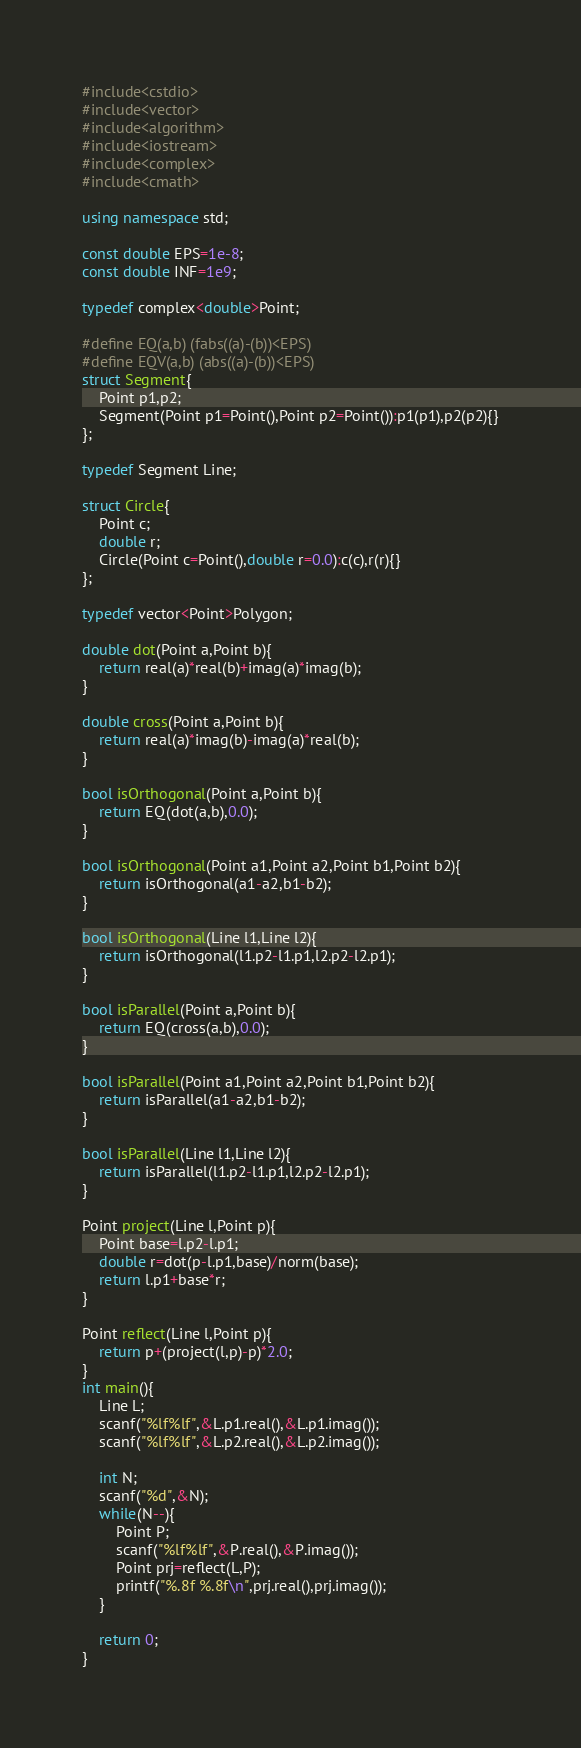<code> <loc_0><loc_0><loc_500><loc_500><_C++_>#include<cstdio>
#include<vector>
#include<algorithm>
#include<iostream>
#include<complex>
#include<cmath>

using namespace std;

const double EPS=1e-8;
const double INF=1e9;

typedef complex<double>Point;

#define EQ(a,b) (fabs((a)-(b))<EPS)
#define EQV(a,b) (abs((a)-(b))<EPS)
struct Segment{
    Point p1,p2;
    Segment(Point p1=Point(),Point p2=Point()):p1(p1),p2(p2){}
};

typedef Segment Line;

struct Circle{
    Point c;
    double r;
    Circle(Point c=Point(),double r=0.0):c(c),r(r){}
};

typedef vector<Point>Polygon;

double dot(Point a,Point b){
    return real(a)*real(b)+imag(a)*imag(b);
}

double cross(Point a,Point b){
    return real(a)*imag(b)-imag(a)*real(b);
}

bool isOrthogonal(Point a,Point b){
    return EQ(dot(a,b),0.0);
}

bool isOrthogonal(Point a1,Point a2,Point b1,Point b2){
    return isOrthogonal(a1-a2,b1-b2);
}

bool isOrthogonal(Line l1,Line l2){
    return isOrthogonal(l1.p2-l1.p1,l2.p2-l2.p1);
}

bool isParallel(Point a,Point b){
    return EQ(cross(a,b),0.0);
}

bool isParallel(Point a1,Point a2,Point b1,Point b2){
    return isParallel(a1-a2,b1-b2);
}

bool isParallel(Line l1,Line l2){
    return isParallel(l1.p2-l1.p1,l2.p2-l2.p1);
}

Point project(Line l,Point p){
    Point base=l.p2-l.p1;
    double r=dot(p-l.p1,base)/norm(base);
    return l.p1+base*r;
}

Point reflect(Line l,Point p){
    return p+(project(l,p)-p)*2.0;
}
int main(){
    Line L;
    scanf("%lf%lf",&L.p1.real(),&L.p1.imag());
    scanf("%lf%lf",&L.p2.real(),&L.p2.imag());

    int N;
    scanf("%d",&N);
    while(N--){
        Point P;
        scanf("%lf%lf",&P.real(),&P.imag());
        Point prj=reflect(L,P);
        printf("%.8f %.8f\n",prj.real(),prj.imag());
    }

    return 0;
}</code> 